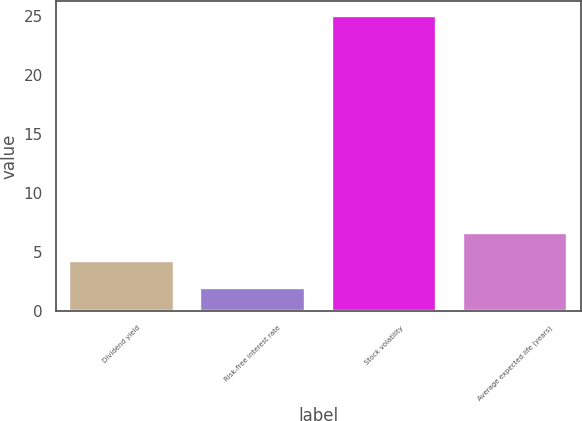Convert chart to OTSL. <chart><loc_0><loc_0><loc_500><loc_500><bar_chart><fcel>Dividend yield<fcel>Risk-free interest rate<fcel>Stock volatility<fcel>Average expected life (years)<nl><fcel>4.3<fcel>2<fcel>25<fcel>6.6<nl></chart> 